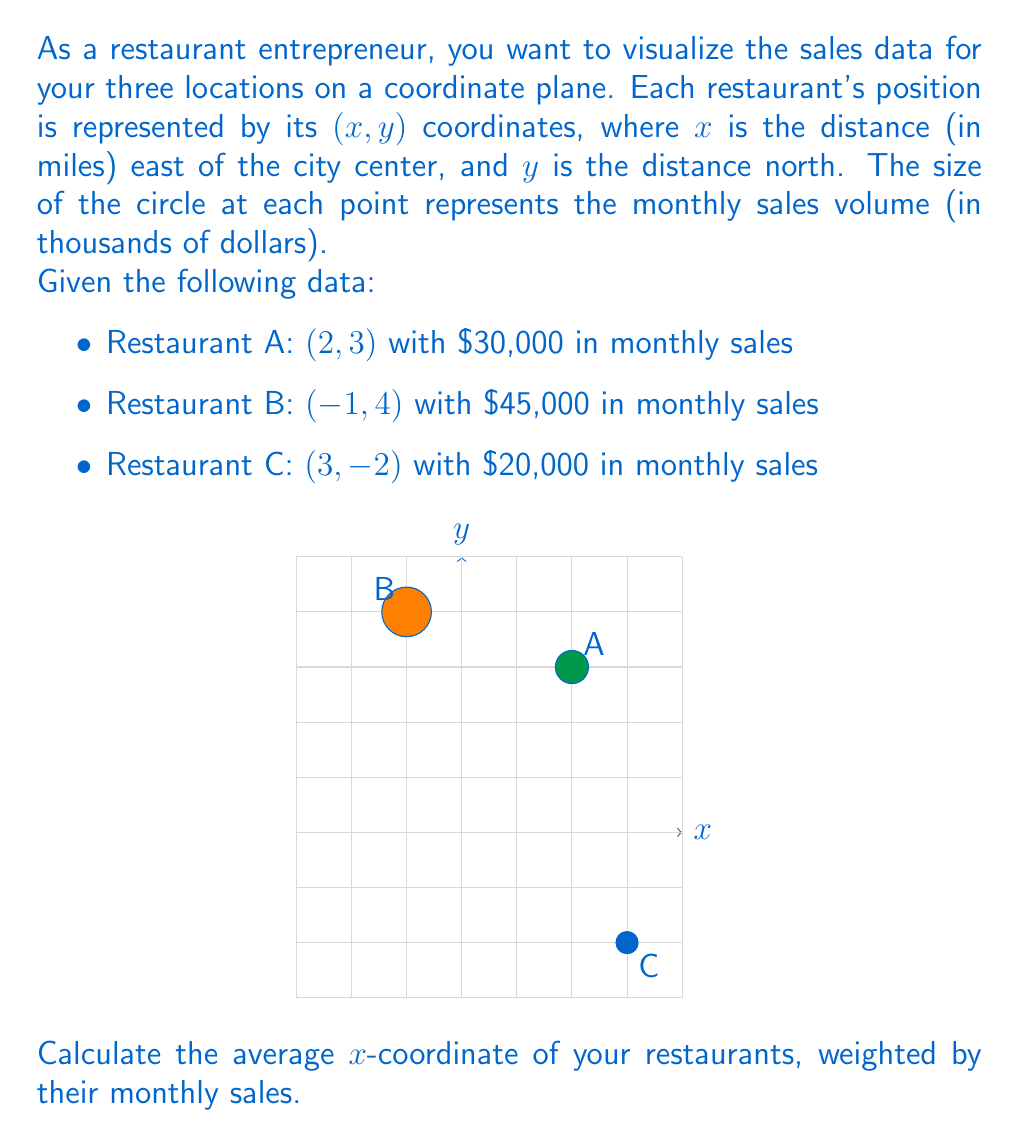Teach me how to tackle this problem. To solve this problem, we need to follow these steps:

1) First, let's recall the formula for a weighted average:
   $$ \text{Weighted Average} = \frac{\sum_{i=1}^n w_i x_i}{\sum_{i=1}^n w_i} $$
   where $w_i$ are the weights (in this case, monthly sales) and $x_i$ are the values (x-coordinates).

2) Now, let's identify our data:
   - Restaurant A: x = 2, weight = 30
   - Restaurant B: x = -1, weight = 45
   - Restaurant C: x = 3, weight = 20

3) Let's calculate the numerator (sum of weighted x-coordinates):
   $$ (2 \times 30) + (-1 \times 45) + (3 \times 20) = 60 - 45 + 60 = 75 $$

4) Now, let's calculate the denominator (sum of weights):
   $$ 30 + 45 + 20 = 95 $$

5) Finally, we can calculate the weighted average:
   $$ \text{Weighted Average} = \frac{75}{95} = 0.7894736842 $$

6) Rounding to two decimal places:
   $$ \text{Weighted Average} \approx 0.79 $$

Therefore, the average x-coordinate of your restaurants, weighted by their monthly sales, is approximately 0.79 miles east of the city center.
Answer: 0.79 miles east 